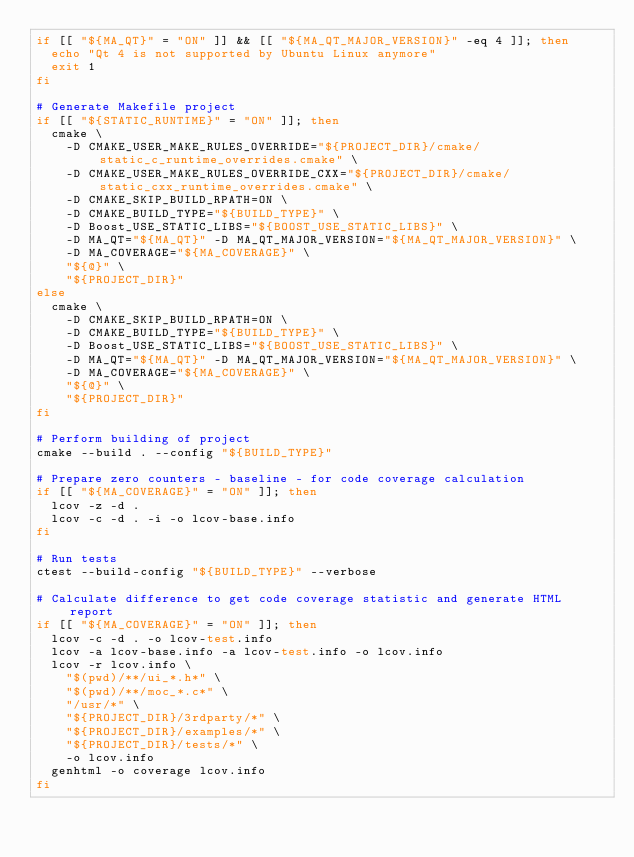Convert code to text. <code><loc_0><loc_0><loc_500><loc_500><_Bash_>if [[ "${MA_QT}" = "ON" ]] && [[ "${MA_QT_MAJOR_VERSION}" -eq 4 ]]; then
  echo "Qt 4 is not supported by Ubuntu Linux anymore"
  exit 1
fi

# Generate Makefile project
if [[ "${STATIC_RUNTIME}" = "ON" ]]; then
  cmake \
    -D CMAKE_USER_MAKE_RULES_OVERRIDE="${PROJECT_DIR}/cmake/static_c_runtime_overrides.cmake" \
    -D CMAKE_USER_MAKE_RULES_OVERRIDE_CXX="${PROJECT_DIR}/cmake/static_cxx_runtime_overrides.cmake" \
    -D CMAKE_SKIP_BUILD_RPATH=ON \
    -D CMAKE_BUILD_TYPE="${BUILD_TYPE}" \
    -D Boost_USE_STATIC_LIBS="${BOOST_USE_STATIC_LIBS}" \
    -D MA_QT="${MA_QT}" -D MA_QT_MAJOR_VERSION="${MA_QT_MAJOR_VERSION}" \
    -D MA_COVERAGE="${MA_COVERAGE}" \
    "${@}" \
    "${PROJECT_DIR}"
else
  cmake \
    -D CMAKE_SKIP_BUILD_RPATH=ON \
    -D CMAKE_BUILD_TYPE="${BUILD_TYPE}" \
    -D Boost_USE_STATIC_LIBS="${BOOST_USE_STATIC_LIBS}" \
    -D MA_QT="${MA_QT}" -D MA_QT_MAJOR_VERSION="${MA_QT_MAJOR_VERSION}" \
    -D MA_COVERAGE="${MA_COVERAGE}" \
    "${@}" \
    "${PROJECT_DIR}"
fi

# Perform building of project
cmake --build . --config "${BUILD_TYPE}"

# Prepare zero counters - baseline - for code coverage calculation
if [[ "${MA_COVERAGE}" = "ON" ]]; then
  lcov -z -d .
  lcov -c -d . -i -o lcov-base.info
fi

# Run tests
ctest --build-config "${BUILD_TYPE}" --verbose

# Calculate difference to get code coverage statistic and generate HTML report
if [[ "${MA_COVERAGE}" = "ON" ]]; then
  lcov -c -d . -o lcov-test.info
  lcov -a lcov-base.info -a lcov-test.info -o lcov.info
  lcov -r lcov.info \
    "$(pwd)/**/ui_*.h*" \
    "$(pwd)/**/moc_*.c*" \
    "/usr/*" \
    "${PROJECT_DIR}/3rdparty/*" \
    "${PROJECT_DIR}/examples/*" \
    "${PROJECT_DIR}/tests/*" \
    -o lcov.info
  genhtml -o coverage lcov.info
fi
</code> 